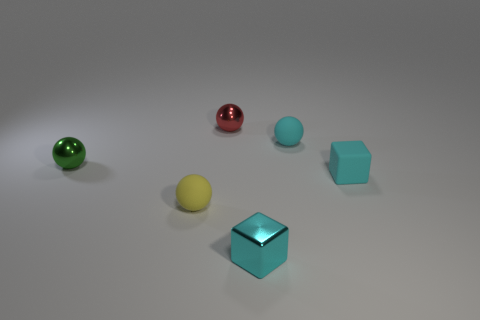Subtract 2 spheres. How many spheres are left? 2 Subtract all cyan spheres. How many spheres are left? 3 Subtract all brown balls. Subtract all purple cylinders. How many balls are left? 4 Add 2 tiny red balls. How many objects exist? 8 Subtract all blocks. How many objects are left? 4 Add 5 green metallic spheres. How many green metallic spheres exist? 6 Subtract 0 green cubes. How many objects are left? 6 Subtract all rubber spheres. Subtract all tiny green balls. How many objects are left? 3 Add 3 tiny matte cubes. How many tiny matte cubes are left? 4 